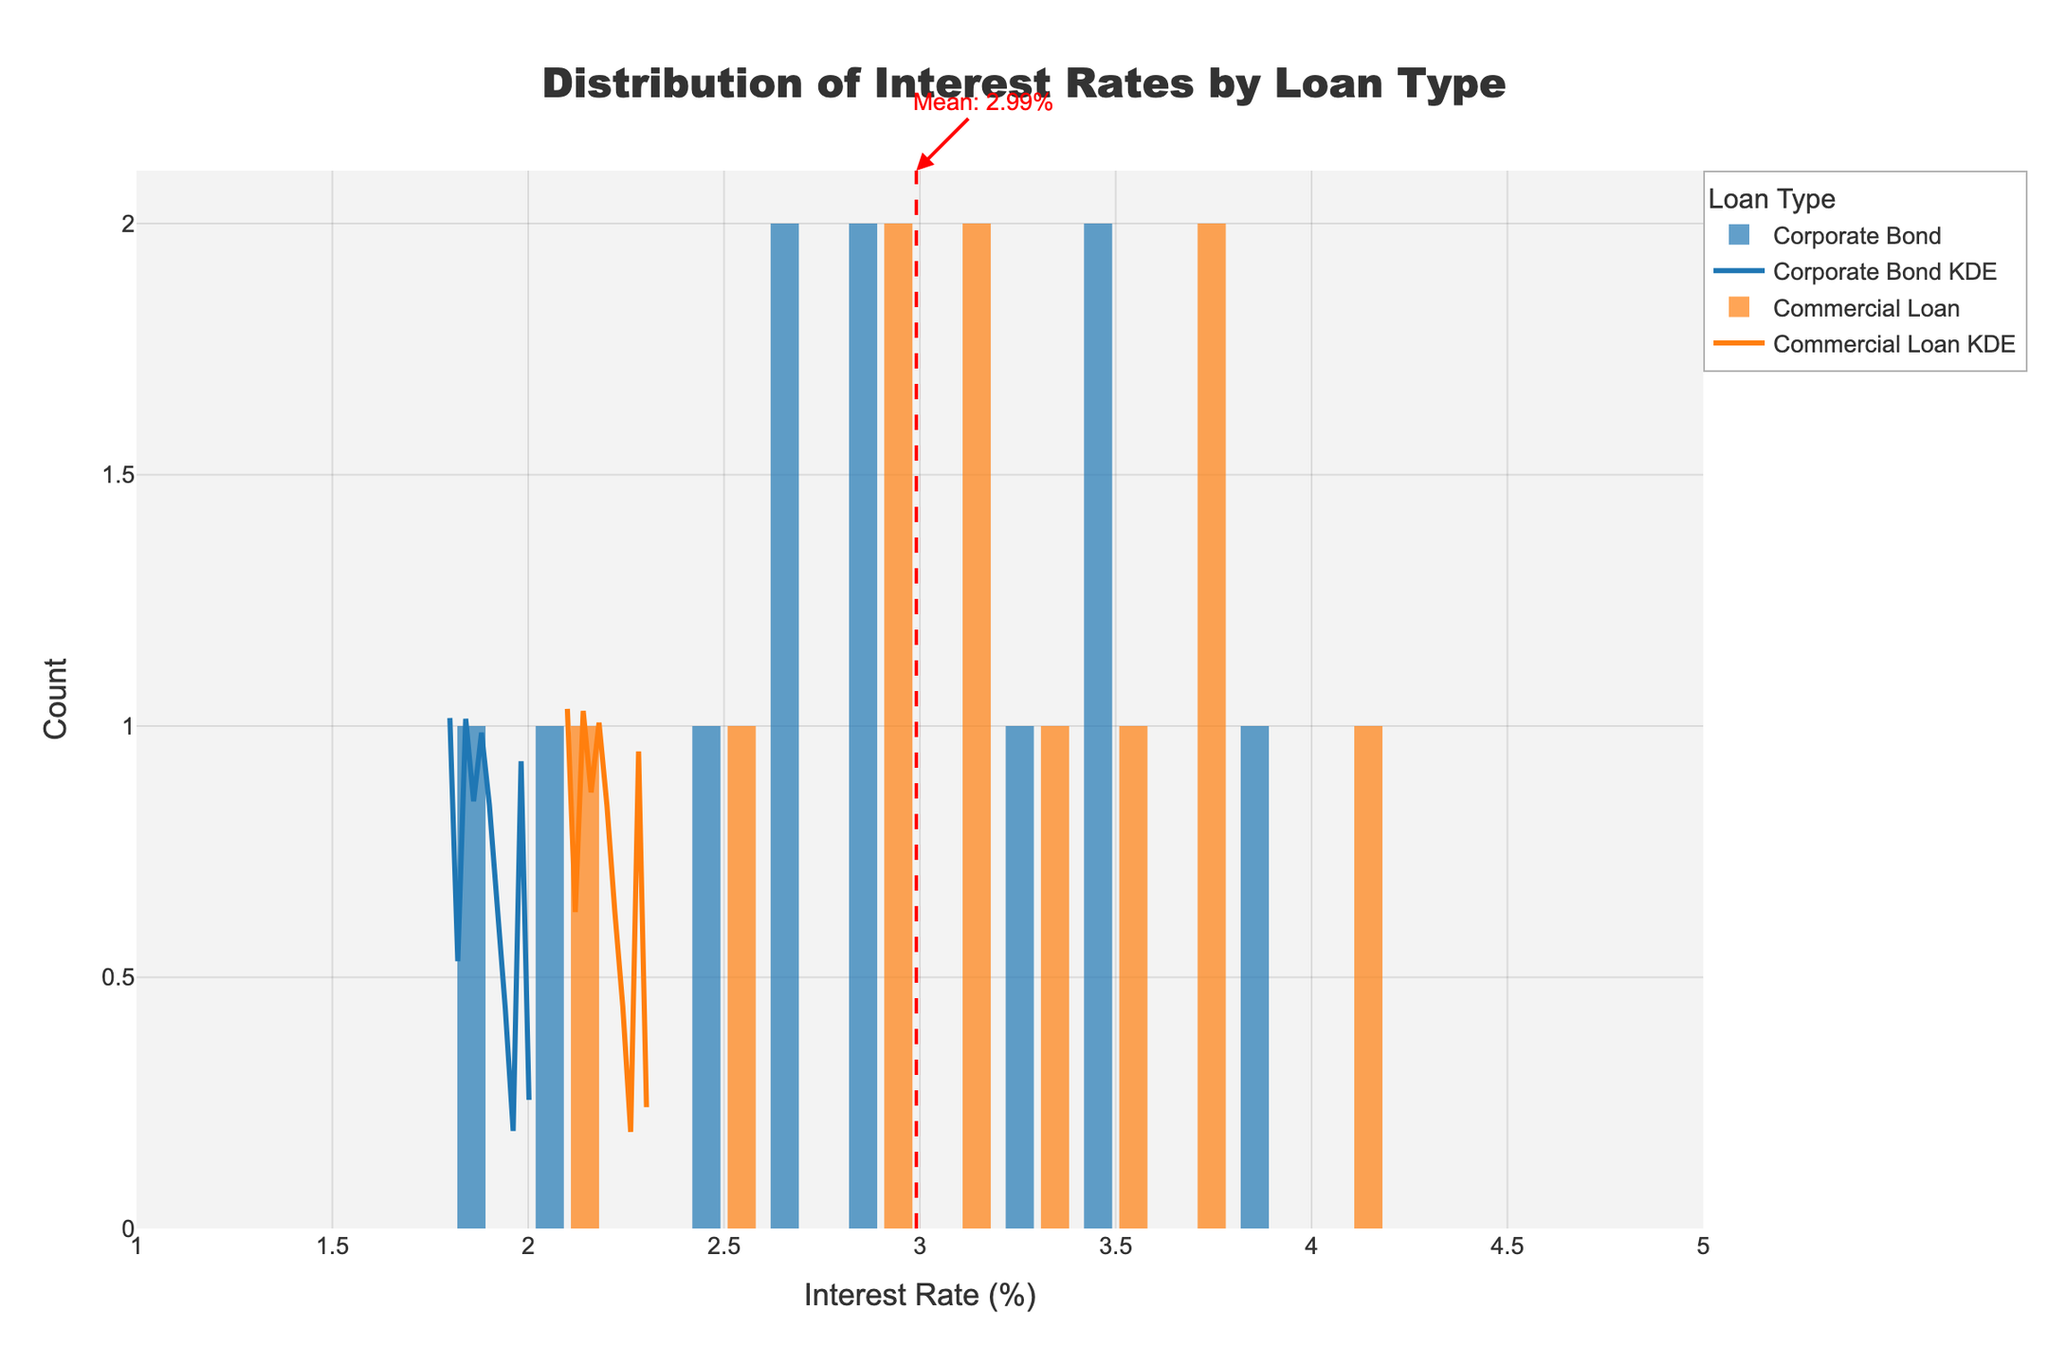What's the title of the figure? The title is usually prominently displayed at the top of the figure. In this case, it's specified in the code provided and should read "Distribution of Interest Rates by Loan Type".
Answer: Distribution of Interest Rates by Loan Type What are the x-axis and y-axis labels? The x-axis usually conveys the variable being measured, while the y-axis shows the frequency/count. According to the code, the x-axis represents "Interest Rate (%)" and the y-axis represents "Count".
Answer: x-axis: Interest Rate (%); y-axis: Count Which loan type has the higher KDE peak? The KDE (Kernel Density Estimate) peaks are the highest points of the density curves. By comparing the heights of the KDE curves, the "Commercial Loan" type shows a higher peak in the figure.
Answer: Commercial Loan What is the general trend in interest rates for Corporate Bonds over the past decade? To establish a trend, observe how the position of the histogram bins and KDE curve for "Corporate Bond" changes over time. It's apparent that the histogram shifts generally from higher interest rates to lower interest rates over the decade.
Answer: Decreasing trend What's the mean interest rate indicated in the figure, and how is it visually represented? The mean interest rate is marked by a vertical dashed red line and highlighted with annotations. According to the figure’s annotations, the mean interest rate is 3.01%.
Answer: 3.01% Which loan type has a wider range of interest rates? To determine the spread, look at the range covered by the histogram bins and KDE curves. "Commercial Loan" covers a wider range of interest rates compared to "Corporate Bond".
Answer: Commercial Loan How do the interest rate distributions differ between Corporate Bonds and Commercial Loans? The "Corporate Bond" histogram and KDE curve are more concentrated around lower interest rates, whereas the "Commercial Loan" histogram and KDE curve show a wider spread and higher peak, indicating more variability.
Answer: Corporate Bonds: more concentrated, lower rates; Commercial Loans: wider range, higher variability What is the interest rate value where the KDE curve for Corporate Bonds reaches its maximum height? To find this, locate the peak of the KDE curve for "Corporate Bond". It lies approximately at 2.8%.
Answer: Around 2.8% How does the count of interest rates at the highest peak compare between Corporate Bonds and Commercial Loans? The peak height (count) for "Commercial Loan" is higher than that for "Corporate Bond", indicating more instances at the most frequent interest rate for loans vs. bonds.
Answer: Higher for Commercial Loans Is there any overlap between the interest rate ranges for the two loan types? By observing where the histograms and KDE curves for both loan types lie, we see that there is an overlap predominantly in the range of approximately 2.5% to 3.5%.
Answer: Yes, from 2.5% to 3.5% 